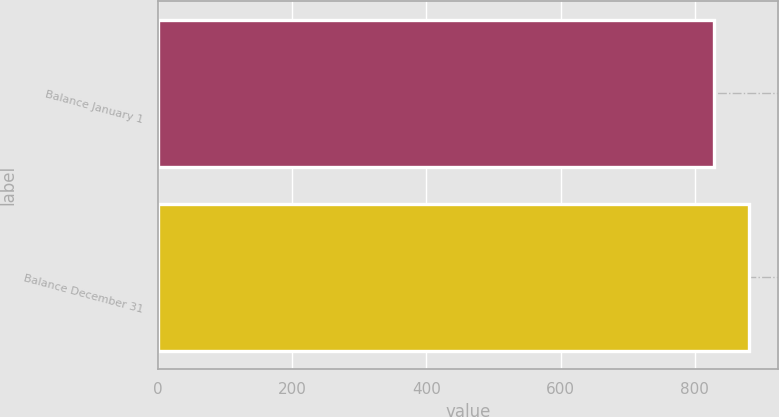<chart> <loc_0><loc_0><loc_500><loc_500><bar_chart><fcel>Balance January 1<fcel>Balance December 31<nl><fcel>828<fcel>880<nl></chart> 